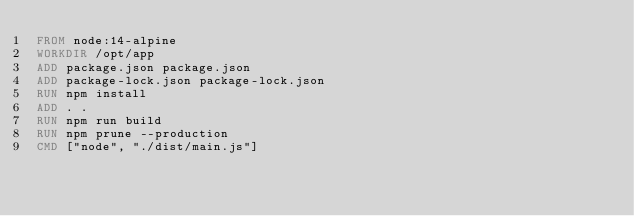Convert code to text. <code><loc_0><loc_0><loc_500><loc_500><_Dockerfile_>FROM node:14-alpine
WORKDIR /opt/app
ADD package.json package.json
ADD package-lock.json package-lock.json
RUN npm install
ADD . .
RUN npm run build
RUN npm prune --production
CMD ["node", "./dist/main.js"]
</code> 